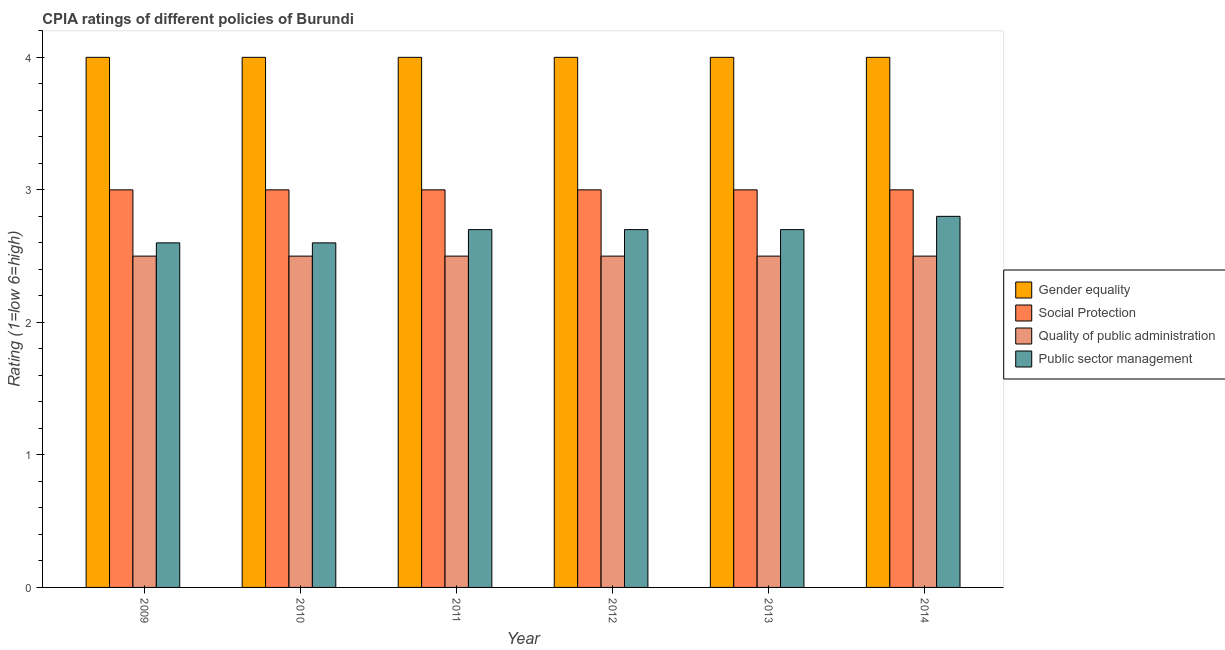Are the number of bars on each tick of the X-axis equal?
Keep it short and to the point. Yes. How many bars are there on the 6th tick from the left?
Offer a very short reply. 4. How many bars are there on the 2nd tick from the right?
Ensure brevity in your answer.  4. Across all years, what is the minimum cpia rating of social protection?
Your answer should be compact. 3. In which year was the cpia rating of gender equality maximum?
Ensure brevity in your answer.  2009. What is the average cpia rating of public sector management per year?
Keep it short and to the point. 2.68. In the year 2014, what is the difference between the cpia rating of public sector management and cpia rating of gender equality?
Your answer should be very brief. 0. In how many years, is the cpia rating of public sector management greater than 0.8?
Provide a short and direct response. 6. Is the difference between the cpia rating of public sector management in 2010 and 2014 greater than the difference between the cpia rating of gender equality in 2010 and 2014?
Ensure brevity in your answer.  No. What is the difference between the highest and the second highest cpia rating of public sector management?
Your response must be concise. 0.1. In how many years, is the cpia rating of public sector management greater than the average cpia rating of public sector management taken over all years?
Keep it short and to the point. 4. Is it the case that in every year, the sum of the cpia rating of public sector management and cpia rating of gender equality is greater than the sum of cpia rating of social protection and cpia rating of quality of public administration?
Provide a short and direct response. No. What does the 4th bar from the left in 2009 represents?
Your response must be concise. Public sector management. What does the 1st bar from the right in 2011 represents?
Make the answer very short. Public sector management. Is it the case that in every year, the sum of the cpia rating of gender equality and cpia rating of social protection is greater than the cpia rating of quality of public administration?
Offer a terse response. Yes. How many years are there in the graph?
Ensure brevity in your answer.  6. What is the difference between two consecutive major ticks on the Y-axis?
Your answer should be very brief. 1. Are the values on the major ticks of Y-axis written in scientific E-notation?
Your answer should be very brief. No. Does the graph contain any zero values?
Keep it short and to the point. No. What is the title of the graph?
Your answer should be very brief. CPIA ratings of different policies of Burundi. What is the label or title of the Y-axis?
Your answer should be compact. Rating (1=low 6=high). What is the Rating (1=low 6=high) of Social Protection in 2009?
Provide a succinct answer. 3. What is the Rating (1=low 6=high) of Quality of public administration in 2009?
Give a very brief answer. 2.5. What is the Rating (1=low 6=high) in Gender equality in 2010?
Make the answer very short. 4. What is the Rating (1=low 6=high) of Gender equality in 2012?
Ensure brevity in your answer.  4. What is the Rating (1=low 6=high) in Social Protection in 2013?
Give a very brief answer. 3. What is the Rating (1=low 6=high) of Quality of public administration in 2013?
Provide a succinct answer. 2.5. What is the Rating (1=low 6=high) in Public sector management in 2013?
Your response must be concise. 2.7. What is the Rating (1=low 6=high) in Gender equality in 2014?
Make the answer very short. 4. What is the Rating (1=low 6=high) of Social Protection in 2014?
Give a very brief answer. 3. What is the Rating (1=low 6=high) of Quality of public administration in 2014?
Offer a very short reply. 2.5. Across all years, what is the maximum Rating (1=low 6=high) of Quality of public administration?
Make the answer very short. 2.5. Across all years, what is the maximum Rating (1=low 6=high) in Public sector management?
Provide a succinct answer. 2.8. Across all years, what is the minimum Rating (1=low 6=high) in Social Protection?
Make the answer very short. 3. Across all years, what is the minimum Rating (1=low 6=high) of Quality of public administration?
Provide a succinct answer. 2.5. Across all years, what is the minimum Rating (1=low 6=high) in Public sector management?
Your answer should be very brief. 2.6. What is the total Rating (1=low 6=high) in Gender equality in the graph?
Offer a very short reply. 24. What is the total Rating (1=low 6=high) in Social Protection in the graph?
Your response must be concise. 18. What is the difference between the Rating (1=low 6=high) of Social Protection in 2009 and that in 2010?
Offer a terse response. 0. What is the difference between the Rating (1=low 6=high) in Public sector management in 2009 and that in 2010?
Give a very brief answer. 0. What is the difference between the Rating (1=low 6=high) of Gender equality in 2009 and that in 2011?
Make the answer very short. 0. What is the difference between the Rating (1=low 6=high) of Public sector management in 2009 and that in 2011?
Provide a short and direct response. -0.1. What is the difference between the Rating (1=low 6=high) in Gender equality in 2009 and that in 2012?
Your answer should be compact. 0. What is the difference between the Rating (1=low 6=high) in Social Protection in 2009 and that in 2012?
Ensure brevity in your answer.  0. What is the difference between the Rating (1=low 6=high) of Quality of public administration in 2009 and that in 2012?
Offer a terse response. 0. What is the difference between the Rating (1=low 6=high) in Gender equality in 2009 and that in 2013?
Give a very brief answer. 0. What is the difference between the Rating (1=low 6=high) in Social Protection in 2009 and that in 2013?
Give a very brief answer. 0. What is the difference between the Rating (1=low 6=high) of Public sector management in 2009 and that in 2014?
Keep it short and to the point. -0.2. What is the difference between the Rating (1=low 6=high) of Quality of public administration in 2010 and that in 2011?
Your answer should be very brief. 0. What is the difference between the Rating (1=low 6=high) of Social Protection in 2010 and that in 2012?
Keep it short and to the point. 0. What is the difference between the Rating (1=low 6=high) of Quality of public administration in 2010 and that in 2012?
Provide a succinct answer. 0. What is the difference between the Rating (1=low 6=high) of Public sector management in 2010 and that in 2012?
Make the answer very short. -0.1. What is the difference between the Rating (1=low 6=high) of Gender equality in 2010 and that in 2013?
Ensure brevity in your answer.  0. What is the difference between the Rating (1=low 6=high) of Quality of public administration in 2010 and that in 2014?
Offer a terse response. 0. What is the difference between the Rating (1=low 6=high) in Social Protection in 2011 and that in 2013?
Provide a short and direct response. 0. What is the difference between the Rating (1=low 6=high) in Social Protection in 2011 and that in 2014?
Your answer should be compact. 0. What is the difference between the Rating (1=low 6=high) in Quality of public administration in 2011 and that in 2014?
Offer a very short reply. 0. What is the difference between the Rating (1=low 6=high) in Public sector management in 2012 and that in 2013?
Your response must be concise. 0. What is the difference between the Rating (1=low 6=high) in Gender equality in 2012 and that in 2014?
Your answer should be very brief. 0. What is the difference between the Rating (1=low 6=high) of Social Protection in 2012 and that in 2014?
Your answer should be compact. 0. What is the difference between the Rating (1=low 6=high) of Public sector management in 2013 and that in 2014?
Your response must be concise. -0.1. What is the difference between the Rating (1=low 6=high) in Social Protection in 2009 and the Rating (1=low 6=high) in Quality of public administration in 2010?
Offer a terse response. 0.5. What is the difference between the Rating (1=low 6=high) of Social Protection in 2009 and the Rating (1=low 6=high) of Public sector management in 2010?
Make the answer very short. 0.4. What is the difference between the Rating (1=low 6=high) of Gender equality in 2009 and the Rating (1=low 6=high) of Social Protection in 2011?
Give a very brief answer. 1. What is the difference between the Rating (1=low 6=high) of Gender equality in 2009 and the Rating (1=low 6=high) of Public sector management in 2011?
Offer a terse response. 1.3. What is the difference between the Rating (1=low 6=high) of Social Protection in 2009 and the Rating (1=low 6=high) of Quality of public administration in 2011?
Keep it short and to the point. 0.5. What is the difference between the Rating (1=low 6=high) of Social Protection in 2009 and the Rating (1=low 6=high) of Quality of public administration in 2012?
Make the answer very short. 0.5. What is the difference between the Rating (1=low 6=high) of Social Protection in 2009 and the Rating (1=low 6=high) of Public sector management in 2012?
Give a very brief answer. 0.3. What is the difference between the Rating (1=low 6=high) in Gender equality in 2009 and the Rating (1=low 6=high) in Social Protection in 2013?
Provide a short and direct response. 1. What is the difference between the Rating (1=low 6=high) of Gender equality in 2009 and the Rating (1=low 6=high) of Public sector management in 2013?
Offer a terse response. 1.3. What is the difference between the Rating (1=low 6=high) of Quality of public administration in 2009 and the Rating (1=low 6=high) of Public sector management in 2013?
Give a very brief answer. -0.2. What is the difference between the Rating (1=low 6=high) in Gender equality in 2009 and the Rating (1=low 6=high) in Social Protection in 2014?
Offer a terse response. 1. What is the difference between the Rating (1=low 6=high) in Gender equality in 2009 and the Rating (1=low 6=high) in Quality of public administration in 2014?
Make the answer very short. 1.5. What is the difference between the Rating (1=low 6=high) in Gender equality in 2009 and the Rating (1=low 6=high) in Public sector management in 2014?
Offer a terse response. 1.2. What is the difference between the Rating (1=low 6=high) of Social Protection in 2009 and the Rating (1=low 6=high) of Public sector management in 2014?
Keep it short and to the point. 0.2. What is the difference between the Rating (1=low 6=high) in Gender equality in 2010 and the Rating (1=low 6=high) in Quality of public administration in 2011?
Provide a short and direct response. 1.5. What is the difference between the Rating (1=low 6=high) in Gender equality in 2010 and the Rating (1=low 6=high) in Public sector management in 2011?
Make the answer very short. 1.3. What is the difference between the Rating (1=low 6=high) in Social Protection in 2010 and the Rating (1=low 6=high) in Quality of public administration in 2012?
Your answer should be compact. 0.5. What is the difference between the Rating (1=low 6=high) in Quality of public administration in 2010 and the Rating (1=low 6=high) in Public sector management in 2012?
Your answer should be very brief. -0.2. What is the difference between the Rating (1=low 6=high) in Gender equality in 2010 and the Rating (1=low 6=high) in Social Protection in 2013?
Give a very brief answer. 1. What is the difference between the Rating (1=low 6=high) in Social Protection in 2010 and the Rating (1=low 6=high) in Public sector management in 2013?
Your answer should be compact. 0.3. What is the difference between the Rating (1=low 6=high) of Quality of public administration in 2010 and the Rating (1=low 6=high) of Public sector management in 2013?
Make the answer very short. -0.2. What is the difference between the Rating (1=low 6=high) of Social Protection in 2010 and the Rating (1=low 6=high) of Quality of public administration in 2014?
Make the answer very short. 0.5. What is the difference between the Rating (1=low 6=high) of Quality of public administration in 2010 and the Rating (1=low 6=high) of Public sector management in 2014?
Your answer should be compact. -0.3. What is the difference between the Rating (1=low 6=high) of Gender equality in 2011 and the Rating (1=low 6=high) of Quality of public administration in 2012?
Offer a very short reply. 1.5. What is the difference between the Rating (1=low 6=high) of Social Protection in 2011 and the Rating (1=low 6=high) of Public sector management in 2012?
Give a very brief answer. 0.3. What is the difference between the Rating (1=low 6=high) in Gender equality in 2011 and the Rating (1=low 6=high) in Social Protection in 2013?
Offer a terse response. 1. What is the difference between the Rating (1=low 6=high) of Gender equality in 2011 and the Rating (1=low 6=high) of Public sector management in 2013?
Make the answer very short. 1.3. What is the difference between the Rating (1=low 6=high) in Gender equality in 2011 and the Rating (1=low 6=high) in Public sector management in 2014?
Offer a terse response. 1.2. What is the difference between the Rating (1=low 6=high) in Gender equality in 2012 and the Rating (1=low 6=high) in Social Protection in 2013?
Your answer should be very brief. 1. What is the difference between the Rating (1=low 6=high) of Gender equality in 2012 and the Rating (1=low 6=high) of Quality of public administration in 2013?
Give a very brief answer. 1.5. What is the difference between the Rating (1=low 6=high) of Social Protection in 2012 and the Rating (1=low 6=high) of Public sector management in 2013?
Offer a very short reply. 0.3. What is the difference between the Rating (1=low 6=high) of Social Protection in 2012 and the Rating (1=low 6=high) of Quality of public administration in 2014?
Keep it short and to the point. 0.5. What is the difference between the Rating (1=low 6=high) in Social Protection in 2012 and the Rating (1=low 6=high) in Public sector management in 2014?
Keep it short and to the point. 0.2. What is the difference between the Rating (1=low 6=high) of Quality of public administration in 2012 and the Rating (1=low 6=high) of Public sector management in 2014?
Your answer should be very brief. -0.3. What is the difference between the Rating (1=low 6=high) in Gender equality in 2013 and the Rating (1=low 6=high) in Quality of public administration in 2014?
Keep it short and to the point. 1.5. What is the difference between the Rating (1=low 6=high) of Social Protection in 2013 and the Rating (1=low 6=high) of Quality of public administration in 2014?
Ensure brevity in your answer.  0.5. What is the difference between the Rating (1=low 6=high) of Social Protection in 2013 and the Rating (1=low 6=high) of Public sector management in 2014?
Provide a short and direct response. 0.2. What is the difference between the Rating (1=low 6=high) in Quality of public administration in 2013 and the Rating (1=low 6=high) in Public sector management in 2014?
Offer a terse response. -0.3. What is the average Rating (1=low 6=high) in Gender equality per year?
Provide a short and direct response. 4. What is the average Rating (1=low 6=high) of Quality of public administration per year?
Make the answer very short. 2.5. What is the average Rating (1=low 6=high) in Public sector management per year?
Provide a succinct answer. 2.68. In the year 2009, what is the difference between the Rating (1=low 6=high) of Gender equality and Rating (1=low 6=high) of Social Protection?
Your answer should be very brief. 1. In the year 2009, what is the difference between the Rating (1=low 6=high) of Gender equality and Rating (1=low 6=high) of Quality of public administration?
Your answer should be very brief. 1.5. In the year 2009, what is the difference between the Rating (1=low 6=high) in Gender equality and Rating (1=low 6=high) in Public sector management?
Offer a very short reply. 1.4. In the year 2009, what is the difference between the Rating (1=low 6=high) in Social Protection and Rating (1=low 6=high) in Quality of public administration?
Your answer should be compact. 0.5. In the year 2010, what is the difference between the Rating (1=low 6=high) of Gender equality and Rating (1=low 6=high) of Public sector management?
Ensure brevity in your answer.  1.4. In the year 2010, what is the difference between the Rating (1=low 6=high) of Quality of public administration and Rating (1=low 6=high) of Public sector management?
Keep it short and to the point. -0.1. In the year 2011, what is the difference between the Rating (1=low 6=high) in Gender equality and Rating (1=low 6=high) in Social Protection?
Provide a short and direct response. 1. In the year 2011, what is the difference between the Rating (1=low 6=high) in Gender equality and Rating (1=low 6=high) in Quality of public administration?
Your response must be concise. 1.5. In the year 2011, what is the difference between the Rating (1=low 6=high) of Gender equality and Rating (1=low 6=high) of Public sector management?
Give a very brief answer. 1.3. In the year 2011, what is the difference between the Rating (1=low 6=high) of Social Protection and Rating (1=low 6=high) of Quality of public administration?
Your answer should be compact. 0.5. In the year 2012, what is the difference between the Rating (1=low 6=high) in Gender equality and Rating (1=low 6=high) in Social Protection?
Keep it short and to the point. 1. In the year 2012, what is the difference between the Rating (1=low 6=high) in Gender equality and Rating (1=low 6=high) in Quality of public administration?
Provide a succinct answer. 1.5. In the year 2012, what is the difference between the Rating (1=low 6=high) of Gender equality and Rating (1=low 6=high) of Public sector management?
Make the answer very short. 1.3. In the year 2012, what is the difference between the Rating (1=low 6=high) of Social Protection and Rating (1=low 6=high) of Quality of public administration?
Your answer should be very brief. 0.5. In the year 2012, what is the difference between the Rating (1=low 6=high) in Social Protection and Rating (1=low 6=high) in Public sector management?
Provide a succinct answer. 0.3. In the year 2012, what is the difference between the Rating (1=low 6=high) in Quality of public administration and Rating (1=low 6=high) in Public sector management?
Offer a terse response. -0.2. In the year 2013, what is the difference between the Rating (1=low 6=high) of Gender equality and Rating (1=low 6=high) of Social Protection?
Give a very brief answer. 1. In the year 2013, what is the difference between the Rating (1=low 6=high) in Gender equality and Rating (1=low 6=high) in Quality of public administration?
Make the answer very short. 1.5. In the year 2013, what is the difference between the Rating (1=low 6=high) in Gender equality and Rating (1=low 6=high) in Public sector management?
Your answer should be compact. 1.3. In the year 2013, what is the difference between the Rating (1=low 6=high) of Quality of public administration and Rating (1=low 6=high) of Public sector management?
Offer a very short reply. -0.2. In the year 2014, what is the difference between the Rating (1=low 6=high) in Gender equality and Rating (1=low 6=high) in Social Protection?
Your response must be concise. 1. In the year 2014, what is the difference between the Rating (1=low 6=high) in Gender equality and Rating (1=low 6=high) in Public sector management?
Give a very brief answer. 1.2. In the year 2014, what is the difference between the Rating (1=low 6=high) of Social Protection and Rating (1=low 6=high) of Public sector management?
Give a very brief answer. 0.2. What is the ratio of the Rating (1=low 6=high) of Gender equality in 2009 to that in 2010?
Your answer should be compact. 1. What is the ratio of the Rating (1=low 6=high) in Quality of public administration in 2009 to that in 2010?
Provide a succinct answer. 1. What is the ratio of the Rating (1=low 6=high) in Public sector management in 2009 to that in 2010?
Offer a terse response. 1. What is the ratio of the Rating (1=low 6=high) in Gender equality in 2009 to that in 2011?
Your answer should be very brief. 1. What is the ratio of the Rating (1=low 6=high) in Social Protection in 2009 to that in 2011?
Offer a terse response. 1. What is the ratio of the Rating (1=low 6=high) of Quality of public administration in 2009 to that in 2011?
Provide a short and direct response. 1. What is the ratio of the Rating (1=low 6=high) in Gender equality in 2009 to that in 2012?
Offer a very short reply. 1. What is the ratio of the Rating (1=low 6=high) in Public sector management in 2009 to that in 2012?
Provide a succinct answer. 0.96. What is the ratio of the Rating (1=low 6=high) of Gender equality in 2009 to that in 2013?
Offer a very short reply. 1. What is the ratio of the Rating (1=low 6=high) of Social Protection in 2009 to that in 2013?
Ensure brevity in your answer.  1. What is the ratio of the Rating (1=low 6=high) in Quality of public administration in 2009 to that in 2014?
Offer a terse response. 1. What is the ratio of the Rating (1=low 6=high) in Gender equality in 2010 to that in 2011?
Your response must be concise. 1. What is the ratio of the Rating (1=low 6=high) in Social Protection in 2010 to that in 2011?
Offer a very short reply. 1. What is the ratio of the Rating (1=low 6=high) of Quality of public administration in 2010 to that in 2011?
Your answer should be compact. 1. What is the ratio of the Rating (1=low 6=high) in Public sector management in 2010 to that in 2011?
Make the answer very short. 0.96. What is the ratio of the Rating (1=low 6=high) of Gender equality in 2010 to that in 2012?
Offer a terse response. 1. What is the ratio of the Rating (1=low 6=high) in Gender equality in 2010 to that in 2013?
Your answer should be compact. 1. What is the ratio of the Rating (1=low 6=high) of Gender equality in 2010 to that in 2014?
Offer a terse response. 1. What is the ratio of the Rating (1=low 6=high) in Quality of public administration in 2010 to that in 2014?
Give a very brief answer. 1. What is the ratio of the Rating (1=low 6=high) in Gender equality in 2011 to that in 2012?
Ensure brevity in your answer.  1. What is the ratio of the Rating (1=low 6=high) of Quality of public administration in 2011 to that in 2012?
Provide a succinct answer. 1. What is the ratio of the Rating (1=low 6=high) of Public sector management in 2011 to that in 2012?
Offer a very short reply. 1. What is the ratio of the Rating (1=low 6=high) of Public sector management in 2011 to that in 2013?
Give a very brief answer. 1. What is the ratio of the Rating (1=low 6=high) in Social Protection in 2011 to that in 2014?
Ensure brevity in your answer.  1. What is the ratio of the Rating (1=low 6=high) of Quality of public administration in 2011 to that in 2014?
Offer a terse response. 1. What is the ratio of the Rating (1=low 6=high) of Public sector management in 2011 to that in 2014?
Offer a terse response. 0.96. What is the ratio of the Rating (1=low 6=high) in Gender equality in 2012 to that in 2013?
Offer a terse response. 1. What is the ratio of the Rating (1=low 6=high) of Social Protection in 2012 to that in 2013?
Offer a very short reply. 1. What is the ratio of the Rating (1=low 6=high) in Quality of public administration in 2012 to that in 2013?
Make the answer very short. 1. What is the ratio of the Rating (1=low 6=high) of Quality of public administration in 2012 to that in 2014?
Give a very brief answer. 1. What is the ratio of the Rating (1=low 6=high) of Social Protection in 2013 to that in 2014?
Provide a succinct answer. 1. What is the difference between the highest and the second highest Rating (1=low 6=high) of Social Protection?
Your answer should be compact. 0. What is the difference between the highest and the second highest Rating (1=low 6=high) of Public sector management?
Your answer should be very brief. 0.1. What is the difference between the highest and the lowest Rating (1=low 6=high) of Gender equality?
Keep it short and to the point. 0. What is the difference between the highest and the lowest Rating (1=low 6=high) of Social Protection?
Make the answer very short. 0. What is the difference between the highest and the lowest Rating (1=low 6=high) in Public sector management?
Keep it short and to the point. 0.2. 